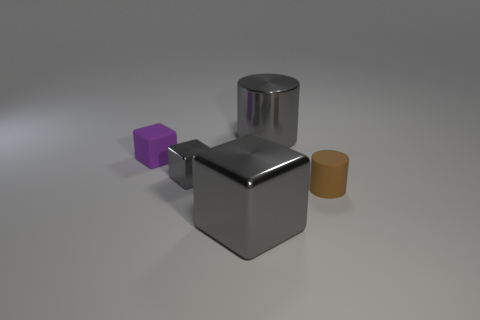What number of gray metal objects are both behind the big gray block and left of the big gray shiny cylinder?
Your answer should be very brief. 1. Are the small purple object and the small object that is right of the large gray shiny cube made of the same material?
Your response must be concise. Yes. How many gray things are blocks or big metal cylinders?
Keep it short and to the point. 3. Are there any other brown cylinders that have the same size as the brown matte cylinder?
Ensure brevity in your answer.  No. The large object that is behind the large shiny thing that is in front of the big gray thing behind the brown thing is made of what material?
Your response must be concise. Metal. Are there the same number of tiny brown cylinders that are behind the big metallic block and tiny brown matte cylinders?
Provide a short and direct response. Yes. Do the large gray object in front of the tiny purple thing and the large gray object that is behind the small purple object have the same material?
Ensure brevity in your answer.  Yes. How many things are brown spheres or shiny objects that are in front of the tiny purple matte block?
Offer a terse response. 2. Are there any other small things of the same shape as the small purple rubber thing?
Provide a succinct answer. Yes. There is a gray metallic object that is right of the large shiny thing that is in front of the thing to the left of the small gray shiny cube; what size is it?
Your answer should be compact. Large. 